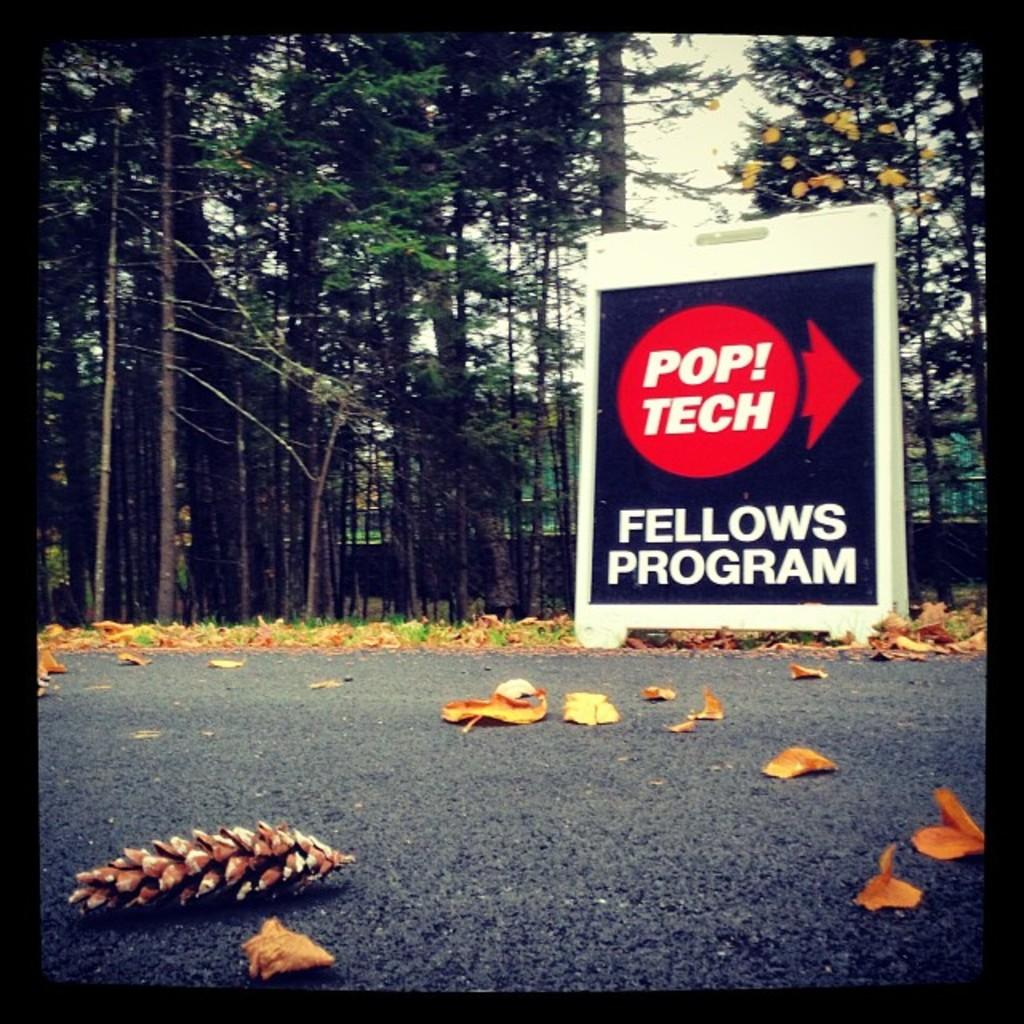What is on the board that is visible in the image? There is a board with writing in the image. What else can be seen on the ground in the image? There are leaves on the road in the image. What type of vegetation is in the background of the image? There are trees in the background of the image. What is visible in the sky in the image? The sky is visible in the background of the image. Where is the grandmother buried in the image? There is no cemetery or mention of a grandmother in the image. 